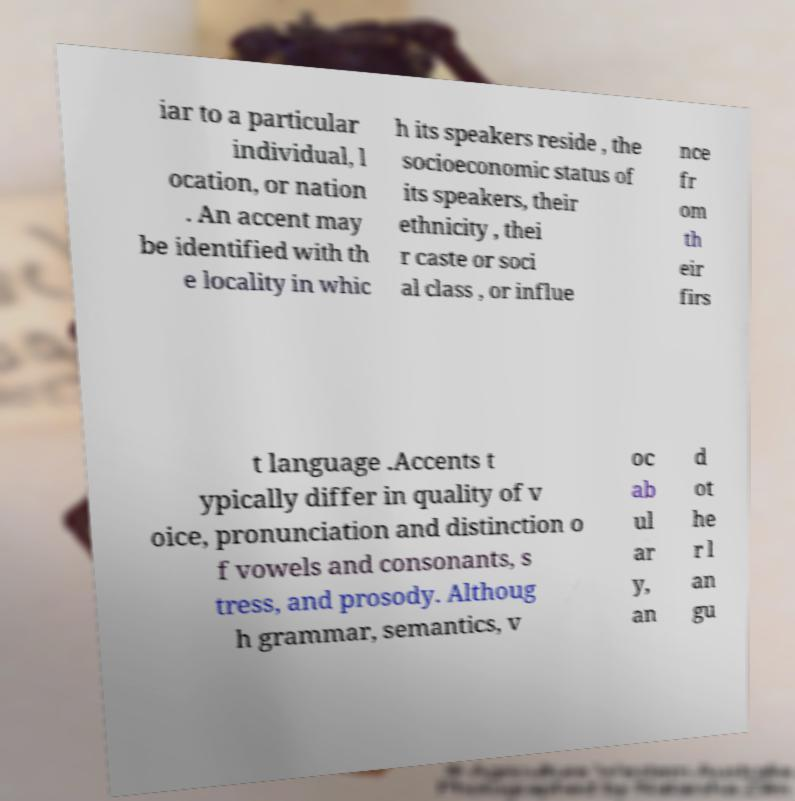Please identify and transcribe the text found in this image. iar to a particular individual, l ocation, or nation . An accent may be identified with th e locality in whic h its speakers reside , the socioeconomic status of its speakers, their ethnicity , thei r caste or soci al class , or influe nce fr om th eir firs t language .Accents t ypically differ in quality of v oice, pronunciation and distinction o f vowels and consonants, s tress, and prosody. Althoug h grammar, semantics, v oc ab ul ar y, an d ot he r l an gu 